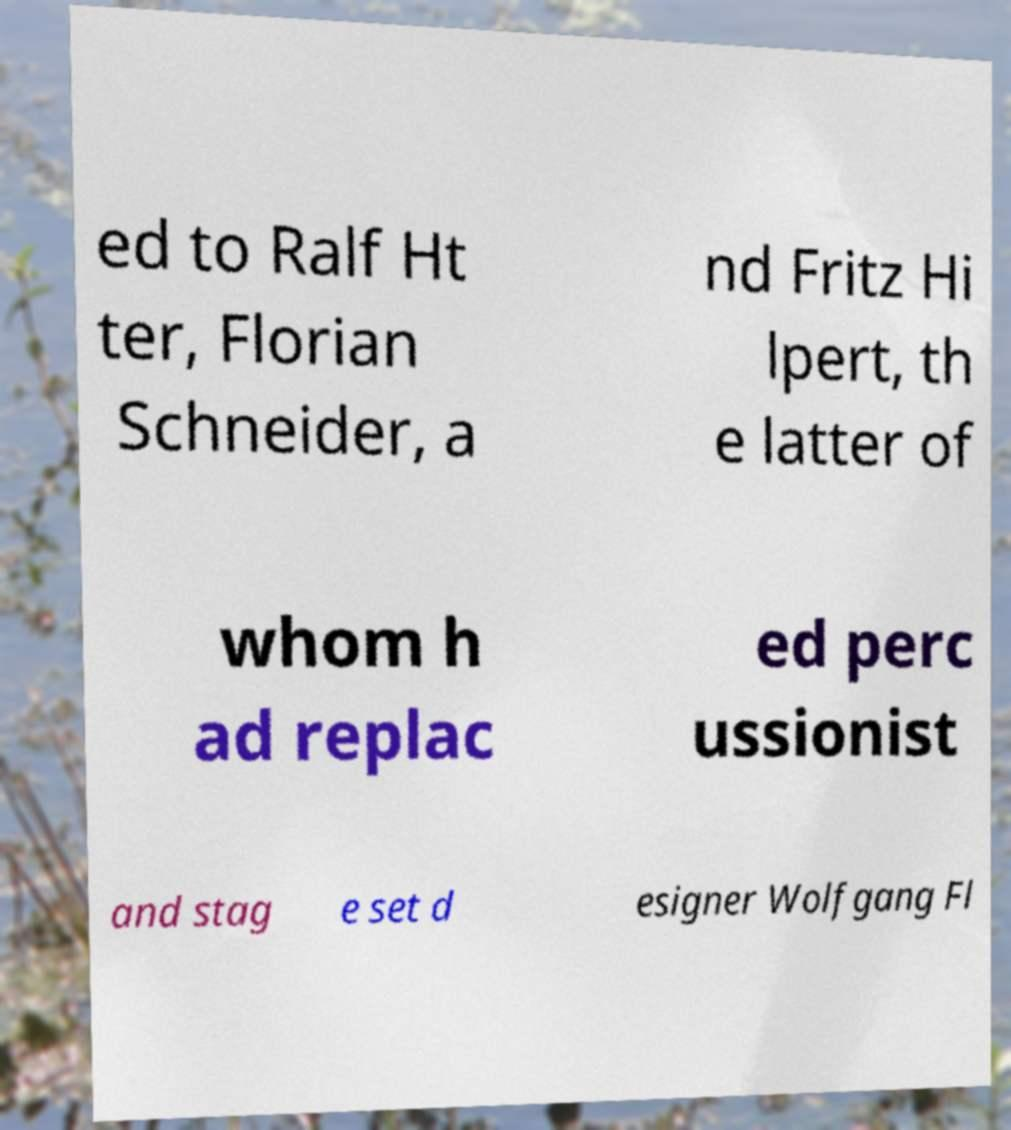Could you extract and type out the text from this image? ed to Ralf Ht ter, Florian Schneider, a nd Fritz Hi lpert, th e latter of whom h ad replac ed perc ussionist and stag e set d esigner Wolfgang Fl 